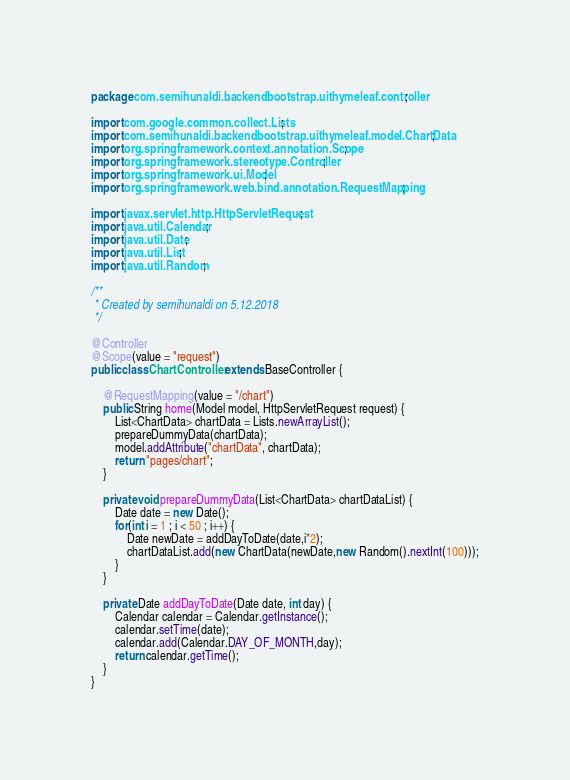Convert code to text. <code><loc_0><loc_0><loc_500><loc_500><_Java_>package com.semihunaldi.backendbootstrap.uithymeleaf.controller;

import com.google.common.collect.Lists;
import com.semihunaldi.backendbootstrap.uithymeleaf.model.ChartData;
import org.springframework.context.annotation.Scope;
import org.springframework.stereotype.Controller;
import org.springframework.ui.Model;
import org.springframework.web.bind.annotation.RequestMapping;

import javax.servlet.http.HttpServletRequest;
import java.util.Calendar;
import java.util.Date;
import java.util.List;
import java.util.Random;

/**
 * Created by semihunaldi on 5.12.2018
 */

@Controller
@Scope(value = "request")
public class ChartController extends BaseController {

	@RequestMapping(value = "/chart")
	public String home(Model model, HttpServletRequest request) {
		List<ChartData> chartData = Lists.newArrayList();
		prepareDummyData(chartData);
		model.addAttribute("chartData", chartData);
		return "pages/chart";
	}

	private void prepareDummyData(List<ChartData> chartDataList) {
		Date date = new Date();
		for(int i = 1 ; i < 50 ; i++) {
			Date newDate = addDayToDate(date,i*2);
			chartDataList.add(new ChartData(newDate,new Random().nextInt(100)));
		}
	}

	private Date addDayToDate(Date date, int day) {
		Calendar calendar = Calendar.getInstance();
		calendar.setTime(date);
		calendar.add(Calendar.DAY_OF_MONTH,day);
		return calendar.getTime();
	}
}
</code> 